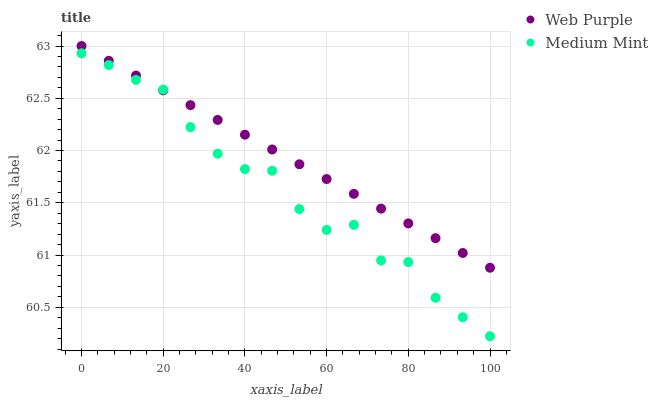Does Medium Mint have the minimum area under the curve?
Answer yes or no. Yes. Does Web Purple have the maximum area under the curve?
Answer yes or no. Yes. Does Web Purple have the minimum area under the curve?
Answer yes or no. No. Is Web Purple the smoothest?
Answer yes or no. Yes. Is Medium Mint the roughest?
Answer yes or no. Yes. Is Web Purple the roughest?
Answer yes or no. No. Does Medium Mint have the lowest value?
Answer yes or no. Yes. Does Web Purple have the lowest value?
Answer yes or no. No. Does Web Purple have the highest value?
Answer yes or no. Yes. Does Web Purple intersect Medium Mint?
Answer yes or no. Yes. Is Web Purple less than Medium Mint?
Answer yes or no. No. Is Web Purple greater than Medium Mint?
Answer yes or no. No. 